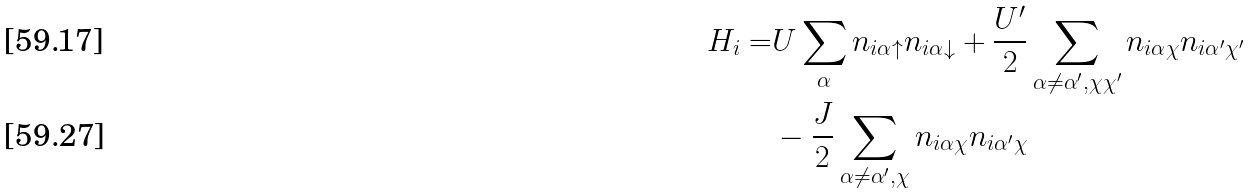Convert formula to latex. <formula><loc_0><loc_0><loc_500><loc_500>H _ { i } = & U \sum _ { \alpha } n _ { i \alpha \uparrow } n _ { i \alpha \downarrow } + \frac { U ^ { \prime } } { 2 } \sum _ { \alpha \neq \alpha ^ { \prime } , \chi \chi ^ { \prime } } n _ { i \alpha \chi } n _ { i \alpha ^ { \prime } \chi ^ { \prime } } \\ & - \frac { J } { 2 } \sum _ { \alpha \neq \alpha ^ { \prime } , \chi } n _ { i \alpha \chi } n _ { i \alpha ^ { \prime } \chi }</formula> 